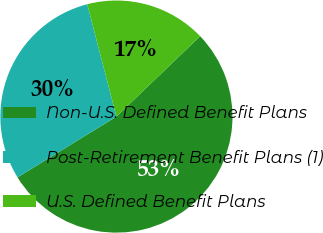Convert chart to OTSL. <chart><loc_0><loc_0><loc_500><loc_500><pie_chart><fcel>Non-U.S. Defined Benefit Plans<fcel>Post-Retirement Benefit Plans (1)<fcel>U.S. Defined Benefit Plans<nl><fcel>53.4%<fcel>29.73%<fcel>16.87%<nl></chart> 